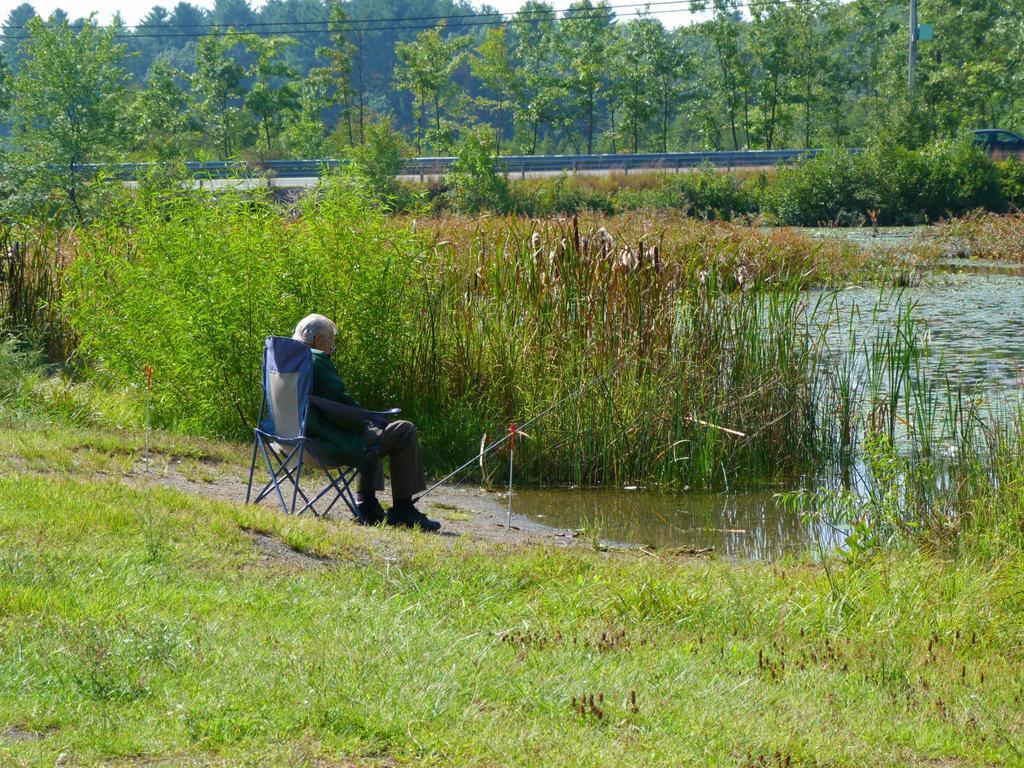How would you summarize this image in a sentence or two? The picture is taken near a pond. In the foreground of the picture there is grass. In the center of the picture there is a man seated in chair. In the center of the picture there are plants and water. In the foreground there is a road. In the background there are trees. 